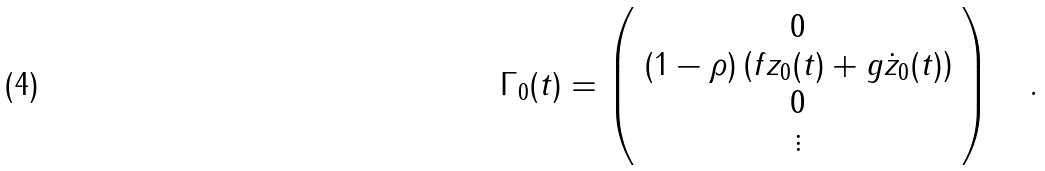Convert formula to latex. <formula><loc_0><loc_0><loc_500><loc_500>\Gamma _ { 0 } ( t ) = \left ( \begin{array} { c } 0 \\ ( 1 - \rho ) \left ( f z _ { 0 } ( t ) + g \dot { z } _ { 0 } ( t ) \right ) \\ 0 \\ \vdots \end{array} \right ) \quad .</formula> 